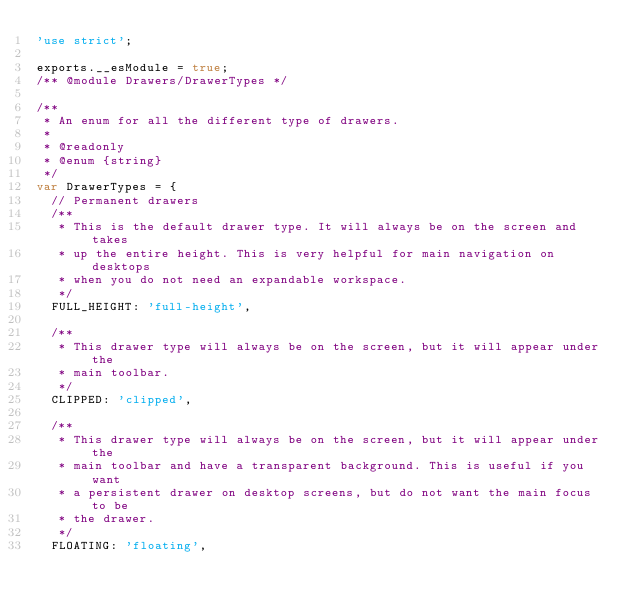<code> <loc_0><loc_0><loc_500><loc_500><_JavaScript_>'use strict';

exports.__esModule = true;
/** @module Drawers/DrawerTypes */

/**
 * An enum for all the different type of drawers.
 *
 * @readonly
 * @enum {string}
 */
var DrawerTypes = {
  // Permanent drawers
  /**
   * This is the default drawer type. It will always be on the screen and takes
   * up the entire height. This is very helpful for main navigation on desktops
   * when you do not need an expandable workspace.
   */
  FULL_HEIGHT: 'full-height',

  /**
   * This drawer type will always be on the screen, but it will appear under the
   * main toolbar.
   */
  CLIPPED: 'clipped',

  /**
   * This drawer type will always be on the screen, but it will appear under the
   * main toolbar and have a transparent background. This is useful if you want
   * a persistent drawer on desktop screens, but do not want the main focus to be
   * the drawer.
   */
  FLOATING: 'floating',
</code> 